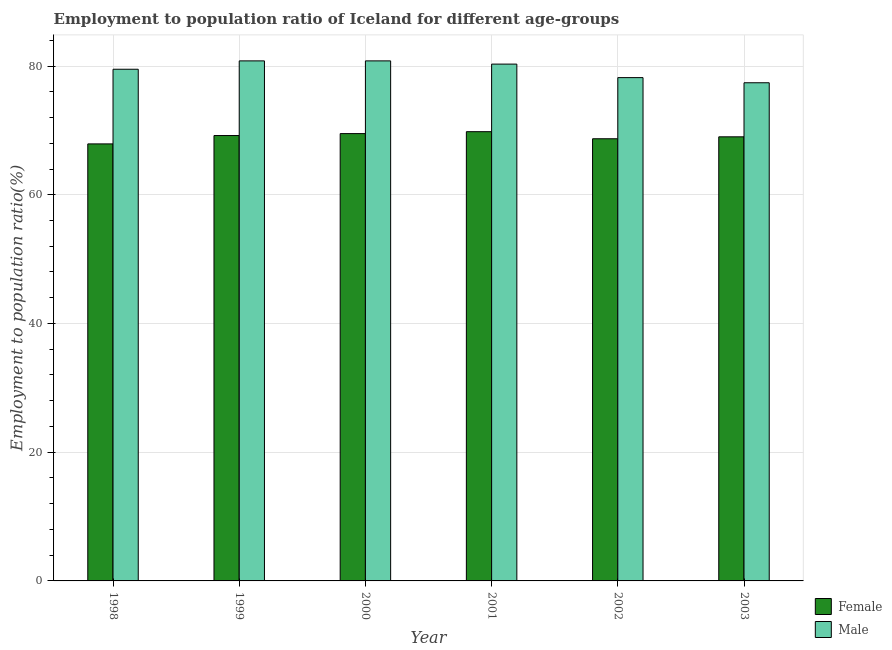Are the number of bars per tick equal to the number of legend labels?
Your answer should be compact. Yes. How many bars are there on the 4th tick from the right?
Offer a very short reply. 2. In how many cases, is the number of bars for a given year not equal to the number of legend labels?
Your answer should be compact. 0. What is the employment to population ratio(female) in 2000?
Ensure brevity in your answer.  69.5. Across all years, what is the maximum employment to population ratio(female)?
Offer a very short reply. 69.8. Across all years, what is the minimum employment to population ratio(female)?
Provide a short and direct response. 67.9. In which year was the employment to population ratio(male) maximum?
Provide a succinct answer. 1999. What is the total employment to population ratio(male) in the graph?
Offer a terse response. 477. What is the difference between the employment to population ratio(female) in 1998 and that in 2001?
Offer a terse response. -1.9. What is the difference between the employment to population ratio(female) in 2003 and the employment to population ratio(male) in 1999?
Your answer should be compact. -0.2. What is the average employment to population ratio(male) per year?
Offer a terse response. 79.5. In the year 2003, what is the difference between the employment to population ratio(male) and employment to population ratio(female)?
Your answer should be compact. 0. What is the ratio of the employment to population ratio(male) in 1998 to that in 2001?
Give a very brief answer. 0.99. What is the difference between the highest and the second highest employment to population ratio(female)?
Provide a succinct answer. 0.3. What is the difference between the highest and the lowest employment to population ratio(male)?
Provide a succinct answer. 3.4. In how many years, is the employment to population ratio(female) greater than the average employment to population ratio(female) taken over all years?
Your answer should be very brief. 3. What does the 2nd bar from the left in 2000 represents?
Give a very brief answer. Male. How many bars are there?
Provide a short and direct response. 12. Are all the bars in the graph horizontal?
Ensure brevity in your answer.  No. Does the graph contain any zero values?
Make the answer very short. No. How are the legend labels stacked?
Your response must be concise. Vertical. What is the title of the graph?
Your response must be concise. Employment to population ratio of Iceland for different age-groups. What is the label or title of the X-axis?
Keep it short and to the point. Year. What is the Employment to population ratio(%) of Female in 1998?
Your answer should be very brief. 67.9. What is the Employment to population ratio(%) in Male in 1998?
Provide a short and direct response. 79.5. What is the Employment to population ratio(%) of Female in 1999?
Keep it short and to the point. 69.2. What is the Employment to population ratio(%) in Male in 1999?
Provide a succinct answer. 80.8. What is the Employment to population ratio(%) of Female in 2000?
Offer a very short reply. 69.5. What is the Employment to population ratio(%) in Male in 2000?
Offer a very short reply. 80.8. What is the Employment to population ratio(%) in Female in 2001?
Offer a terse response. 69.8. What is the Employment to population ratio(%) in Male in 2001?
Offer a terse response. 80.3. What is the Employment to population ratio(%) of Female in 2002?
Keep it short and to the point. 68.7. What is the Employment to population ratio(%) of Male in 2002?
Your answer should be very brief. 78.2. What is the Employment to population ratio(%) in Female in 2003?
Provide a short and direct response. 69. What is the Employment to population ratio(%) in Male in 2003?
Keep it short and to the point. 77.4. Across all years, what is the maximum Employment to population ratio(%) in Female?
Ensure brevity in your answer.  69.8. Across all years, what is the maximum Employment to population ratio(%) of Male?
Your response must be concise. 80.8. Across all years, what is the minimum Employment to population ratio(%) of Female?
Keep it short and to the point. 67.9. Across all years, what is the minimum Employment to population ratio(%) of Male?
Ensure brevity in your answer.  77.4. What is the total Employment to population ratio(%) in Female in the graph?
Your answer should be very brief. 414.1. What is the total Employment to population ratio(%) in Male in the graph?
Provide a short and direct response. 477. What is the difference between the Employment to population ratio(%) in Female in 1998 and that in 1999?
Offer a very short reply. -1.3. What is the difference between the Employment to population ratio(%) in Male in 1998 and that in 1999?
Provide a short and direct response. -1.3. What is the difference between the Employment to population ratio(%) in Male in 1998 and that in 2001?
Keep it short and to the point. -0.8. What is the difference between the Employment to population ratio(%) of Male in 1998 and that in 2003?
Ensure brevity in your answer.  2.1. What is the difference between the Employment to population ratio(%) in Female in 1999 and that in 2000?
Make the answer very short. -0.3. What is the difference between the Employment to population ratio(%) of Male in 1999 and that in 2000?
Keep it short and to the point. 0. What is the difference between the Employment to population ratio(%) in Male in 1999 and that in 2001?
Keep it short and to the point. 0.5. What is the difference between the Employment to population ratio(%) in Female in 1999 and that in 2002?
Give a very brief answer. 0.5. What is the difference between the Employment to population ratio(%) of Male in 1999 and that in 2002?
Your answer should be very brief. 2.6. What is the difference between the Employment to population ratio(%) of Male in 1999 and that in 2003?
Your response must be concise. 3.4. What is the difference between the Employment to population ratio(%) in Female in 2000 and that in 2002?
Provide a succinct answer. 0.8. What is the difference between the Employment to population ratio(%) in Male in 2001 and that in 2002?
Ensure brevity in your answer.  2.1. What is the difference between the Employment to population ratio(%) in Male in 2001 and that in 2003?
Keep it short and to the point. 2.9. What is the difference between the Employment to population ratio(%) in Female in 2002 and that in 2003?
Provide a short and direct response. -0.3. What is the difference between the Employment to population ratio(%) of Male in 2002 and that in 2003?
Provide a succinct answer. 0.8. What is the difference between the Employment to population ratio(%) of Female in 1998 and the Employment to population ratio(%) of Male in 1999?
Provide a succinct answer. -12.9. What is the difference between the Employment to population ratio(%) of Female in 1998 and the Employment to population ratio(%) of Male in 2002?
Offer a very short reply. -10.3. What is the difference between the Employment to population ratio(%) of Female in 1998 and the Employment to population ratio(%) of Male in 2003?
Provide a succinct answer. -9.5. What is the difference between the Employment to population ratio(%) in Female in 1999 and the Employment to population ratio(%) in Male in 2000?
Offer a terse response. -11.6. What is the difference between the Employment to population ratio(%) in Female in 1999 and the Employment to population ratio(%) in Male in 2001?
Provide a succinct answer. -11.1. What is the difference between the Employment to population ratio(%) of Female in 1999 and the Employment to population ratio(%) of Male in 2002?
Make the answer very short. -9. What is the difference between the Employment to population ratio(%) of Female in 1999 and the Employment to population ratio(%) of Male in 2003?
Your response must be concise. -8.2. What is the difference between the Employment to population ratio(%) in Female in 2000 and the Employment to population ratio(%) in Male in 2001?
Make the answer very short. -10.8. What is the difference between the Employment to population ratio(%) in Female in 2000 and the Employment to population ratio(%) in Male in 2003?
Offer a very short reply. -7.9. What is the difference between the Employment to population ratio(%) of Female in 2002 and the Employment to population ratio(%) of Male in 2003?
Offer a terse response. -8.7. What is the average Employment to population ratio(%) of Female per year?
Make the answer very short. 69.02. What is the average Employment to population ratio(%) in Male per year?
Ensure brevity in your answer.  79.5. What is the ratio of the Employment to population ratio(%) in Female in 1998 to that in 1999?
Keep it short and to the point. 0.98. What is the ratio of the Employment to population ratio(%) of Male in 1998 to that in 1999?
Provide a short and direct response. 0.98. What is the ratio of the Employment to population ratio(%) in Male in 1998 to that in 2000?
Ensure brevity in your answer.  0.98. What is the ratio of the Employment to population ratio(%) of Female in 1998 to that in 2001?
Your answer should be compact. 0.97. What is the ratio of the Employment to population ratio(%) of Female in 1998 to that in 2002?
Keep it short and to the point. 0.99. What is the ratio of the Employment to population ratio(%) of Male in 1998 to that in 2002?
Your answer should be very brief. 1.02. What is the ratio of the Employment to population ratio(%) in Female in 1998 to that in 2003?
Offer a terse response. 0.98. What is the ratio of the Employment to population ratio(%) of Male in 1998 to that in 2003?
Make the answer very short. 1.03. What is the ratio of the Employment to population ratio(%) in Female in 1999 to that in 2000?
Offer a terse response. 1. What is the ratio of the Employment to population ratio(%) in Male in 1999 to that in 2000?
Make the answer very short. 1. What is the ratio of the Employment to population ratio(%) of Female in 1999 to that in 2002?
Provide a short and direct response. 1.01. What is the ratio of the Employment to population ratio(%) of Male in 1999 to that in 2002?
Offer a very short reply. 1.03. What is the ratio of the Employment to population ratio(%) in Female in 1999 to that in 2003?
Your answer should be compact. 1. What is the ratio of the Employment to population ratio(%) in Male in 1999 to that in 2003?
Your response must be concise. 1.04. What is the ratio of the Employment to population ratio(%) in Female in 2000 to that in 2001?
Provide a short and direct response. 1. What is the ratio of the Employment to population ratio(%) in Female in 2000 to that in 2002?
Your answer should be very brief. 1.01. What is the ratio of the Employment to population ratio(%) in Male in 2000 to that in 2002?
Your answer should be very brief. 1.03. What is the ratio of the Employment to population ratio(%) of Female in 2000 to that in 2003?
Ensure brevity in your answer.  1.01. What is the ratio of the Employment to population ratio(%) of Male in 2000 to that in 2003?
Ensure brevity in your answer.  1.04. What is the ratio of the Employment to population ratio(%) of Male in 2001 to that in 2002?
Your response must be concise. 1.03. What is the ratio of the Employment to population ratio(%) in Female in 2001 to that in 2003?
Offer a terse response. 1.01. What is the ratio of the Employment to population ratio(%) in Male in 2001 to that in 2003?
Provide a succinct answer. 1.04. What is the ratio of the Employment to population ratio(%) of Female in 2002 to that in 2003?
Make the answer very short. 1. What is the ratio of the Employment to population ratio(%) in Male in 2002 to that in 2003?
Provide a short and direct response. 1.01. What is the difference between the highest and the second highest Employment to population ratio(%) of Female?
Make the answer very short. 0.3. 